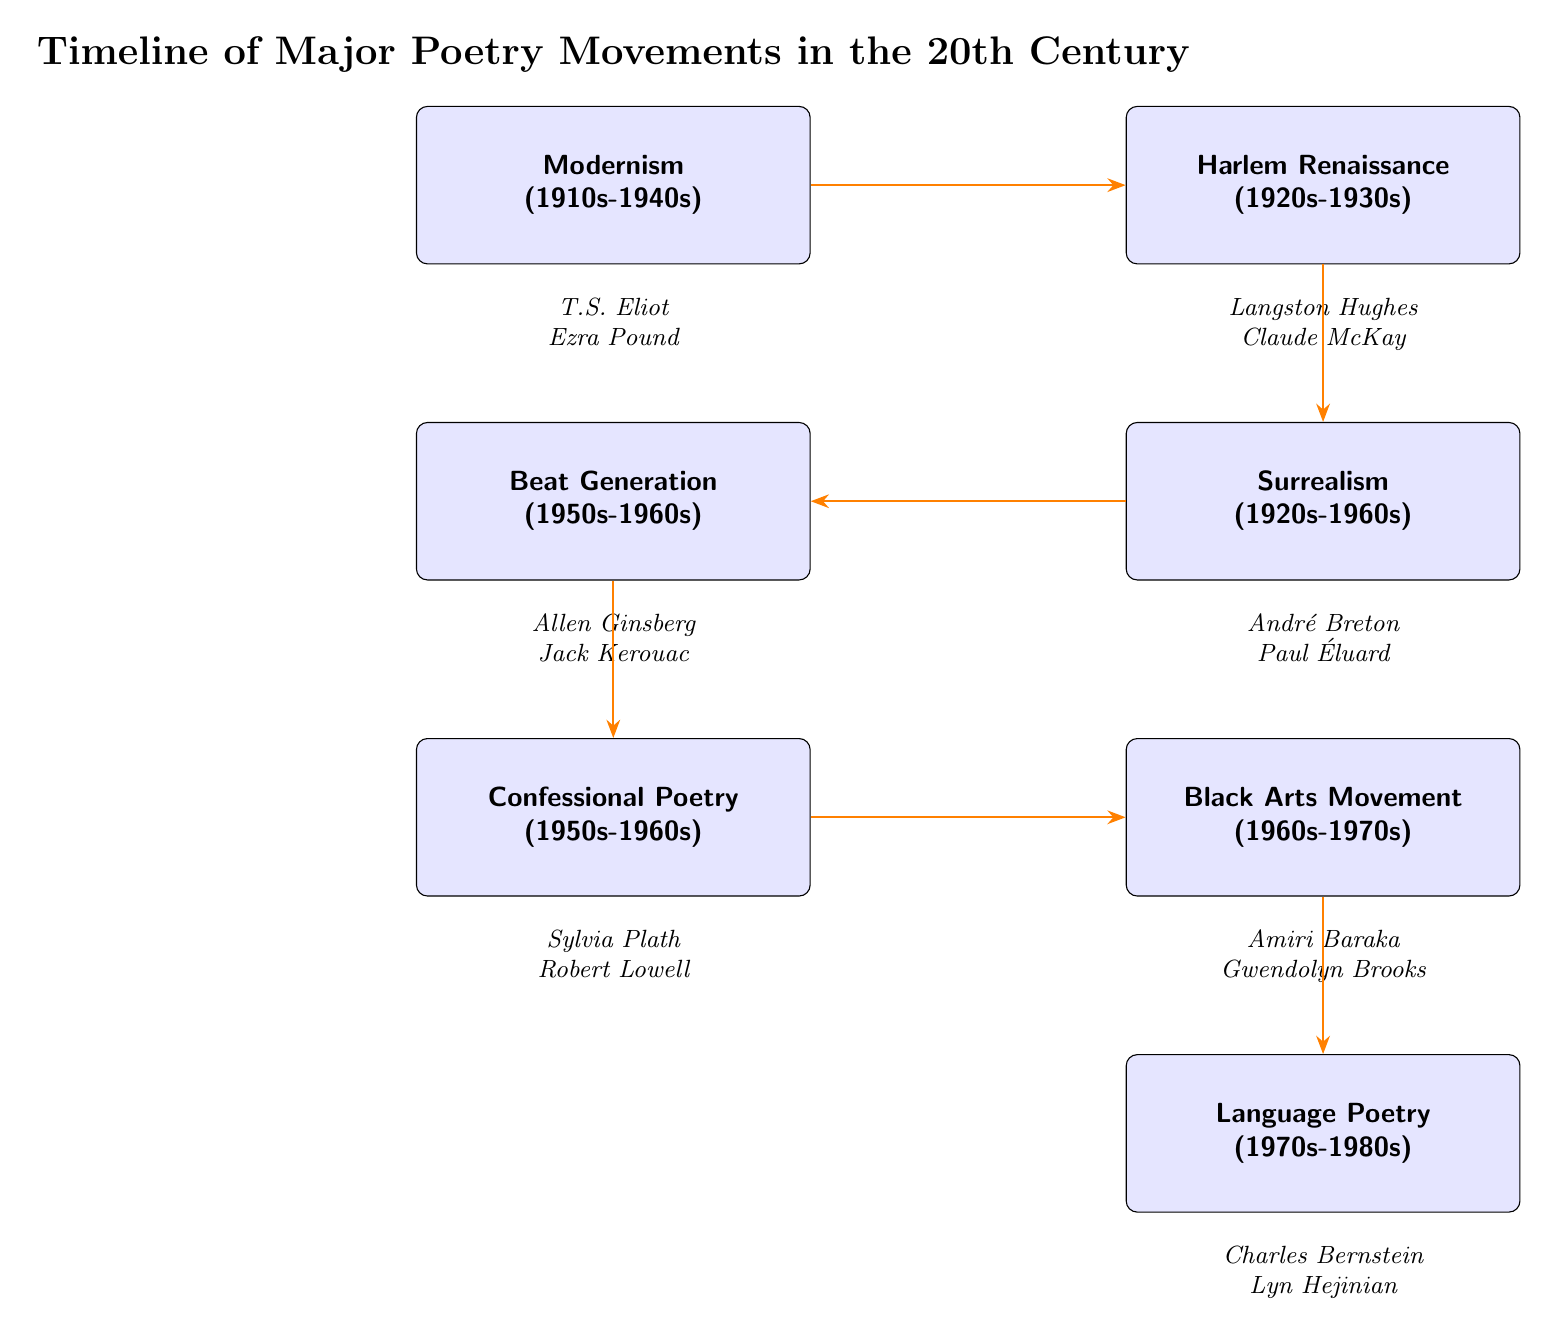What is the first poetry movement listed in the diagram? The first node in the diagram is labeled "Modernism" which is located at the top left position. Thus, it represents the initial movement.
Answer: Modernism How many poets are associated with the Black Arts Movement? Under the "Black Arts Movement" node, there are two poets listed: "Amiri Baraka" and "Gwendolyn Brooks." This is directly seen from the node and the poets listed underneath it.
Answer: 2 Which movement comes after the Surrealism movement? The arrow pointing down from the "Surrealism" node leads to the "Beat Generation" node, indicating the direct sequential relationship between these two movements in the timeline.
Answer: Beat Generation Who are the poets associated with Confessional Poetry? Looking under the "Confessional Poetry" node, the poets listed there are "Sylvia Plath" and "Robert Lowell," as evidenced by their direct placement beneath the node.
Answer: Sylvia Plath, Robert Lowell What is the last movement in the timeline? The last node at the bottom of the diagram is labeled "Language Poetry," indicating that it is the final movement illustrated in this timeline of poetry movements.
Answer: Language Poetry Which movement is represented by Langston Hughes? Langston Hughes is listed under the "Harlem Renaissance" node, which is directly next to the "Modernism" node on the right side of the diagram. Thus, this movement is associated with him.
Answer: Harlem Renaissance What is the time period for the Beat Generation? The "Beat Generation" node specifies the time frame as "1950s-1960s," which provides the relevant temporal context for this movement displayed in the diagram.
Answer: 1950s-1960s How does the Language Poetry movement relate to the other movements? Language Poetry, at the bottom of the timeline, is the final movement that connects sequentially from the Black Arts Movement via an arrow, indicating its chronological positioning in the flow of the diagram.
Answer: Sequentially last 